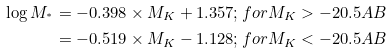Convert formula to latex. <formula><loc_0><loc_0><loc_500><loc_500>\log M _ { ^ { * } } & = - 0 . 3 9 8 \times M _ { K } + 1 . 3 5 7 ; f o r M _ { K } > - 2 0 . 5 A B \\ & = - 0 . 5 1 9 \times M _ { K } - 1 . 1 2 8 ; f o r M _ { K } < - 2 0 . 5 A B</formula> 